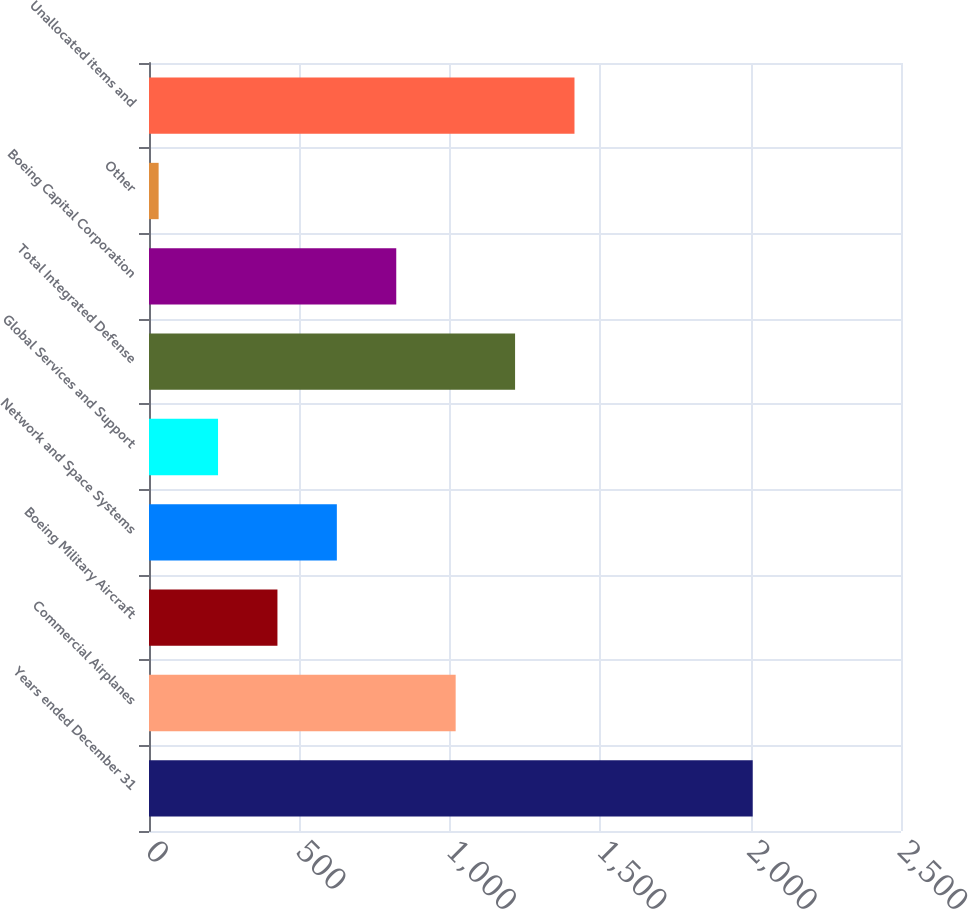Convert chart to OTSL. <chart><loc_0><loc_0><loc_500><loc_500><bar_chart><fcel>Years ended December 31<fcel>Commercial Airplanes<fcel>Boeing Military Aircraft<fcel>Network and Space Systems<fcel>Global Services and Support<fcel>Total Integrated Defense<fcel>Boeing Capital Corporation<fcel>Other<fcel>Unallocated items and<nl><fcel>2007<fcel>1019.5<fcel>427<fcel>624.5<fcel>229.5<fcel>1217<fcel>822<fcel>32<fcel>1414.5<nl></chart> 